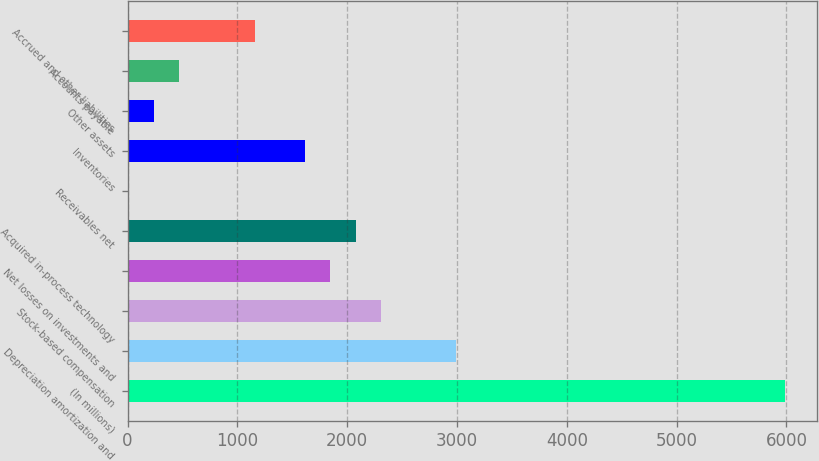<chart> <loc_0><loc_0><loc_500><loc_500><bar_chart><fcel>(In millions)<fcel>Depreciation amortization and<fcel>Stock-based compensation<fcel>Net losses on investments and<fcel>Acquired in-process technology<fcel>Receivables net<fcel>Inventories<fcel>Other assets<fcel>Accounts payable<fcel>Accrued and other liabilities<nl><fcel>5982.8<fcel>2995.4<fcel>2306<fcel>1846.4<fcel>2076.2<fcel>8<fcel>1616.6<fcel>237.8<fcel>467.6<fcel>1157<nl></chart> 